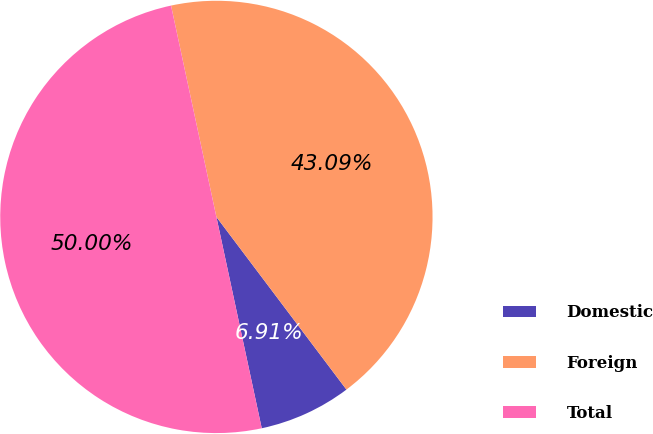<chart> <loc_0><loc_0><loc_500><loc_500><pie_chart><fcel>Domestic<fcel>Foreign<fcel>Total<nl><fcel>6.91%<fcel>43.09%<fcel>50.0%<nl></chart> 